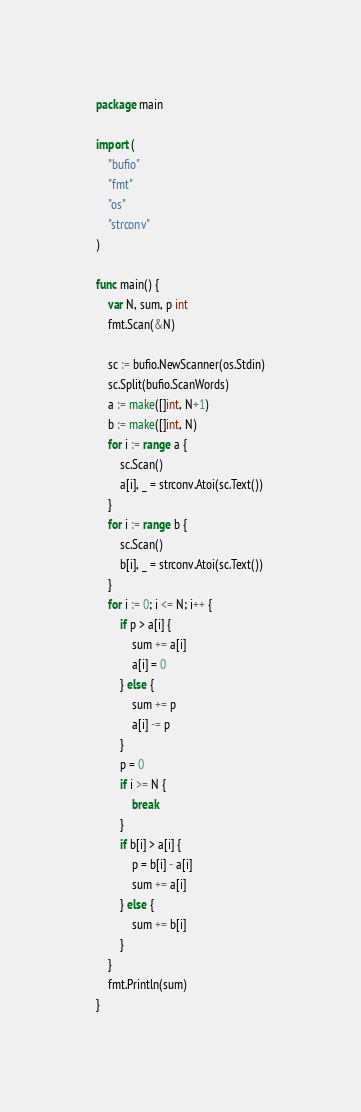Convert code to text. <code><loc_0><loc_0><loc_500><loc_500><_Go_>package main

import (
	"bufio"
	"fmt"
	"os"
	"strconv"
)

func main() {
	var N, sum, p int
	fmt.Scan(&N)

	sc := bufio.NewScanner(os.Stdin)
	sc.Split(bufio.ScanWords)
	a := make([]int, N+1)
	b := make([]int, N)
	for i := range a {
		sc.Scan()
		a[i], _ = strconv.Atoi(sc.Text())
	}
	for i := range b {
		sc.Scan()
		b[i], _ = strconv.Atoi(sc.Text())
	}
	for i := 0; i <= N; i++ {
		if p > a[i] {
			sum += a[i]
			a[i] = 0
		} else {
			sum += p
			a[i] -= p
		}
		p = 0
		if i >= N {
			break
		}
		if b[i] > a[i] {
			p = b[i] - a[i]
			sum += a[i]
		} else {
			sum += b[i]
		}
	}
	fmt.Println(sum)
}
</code> 